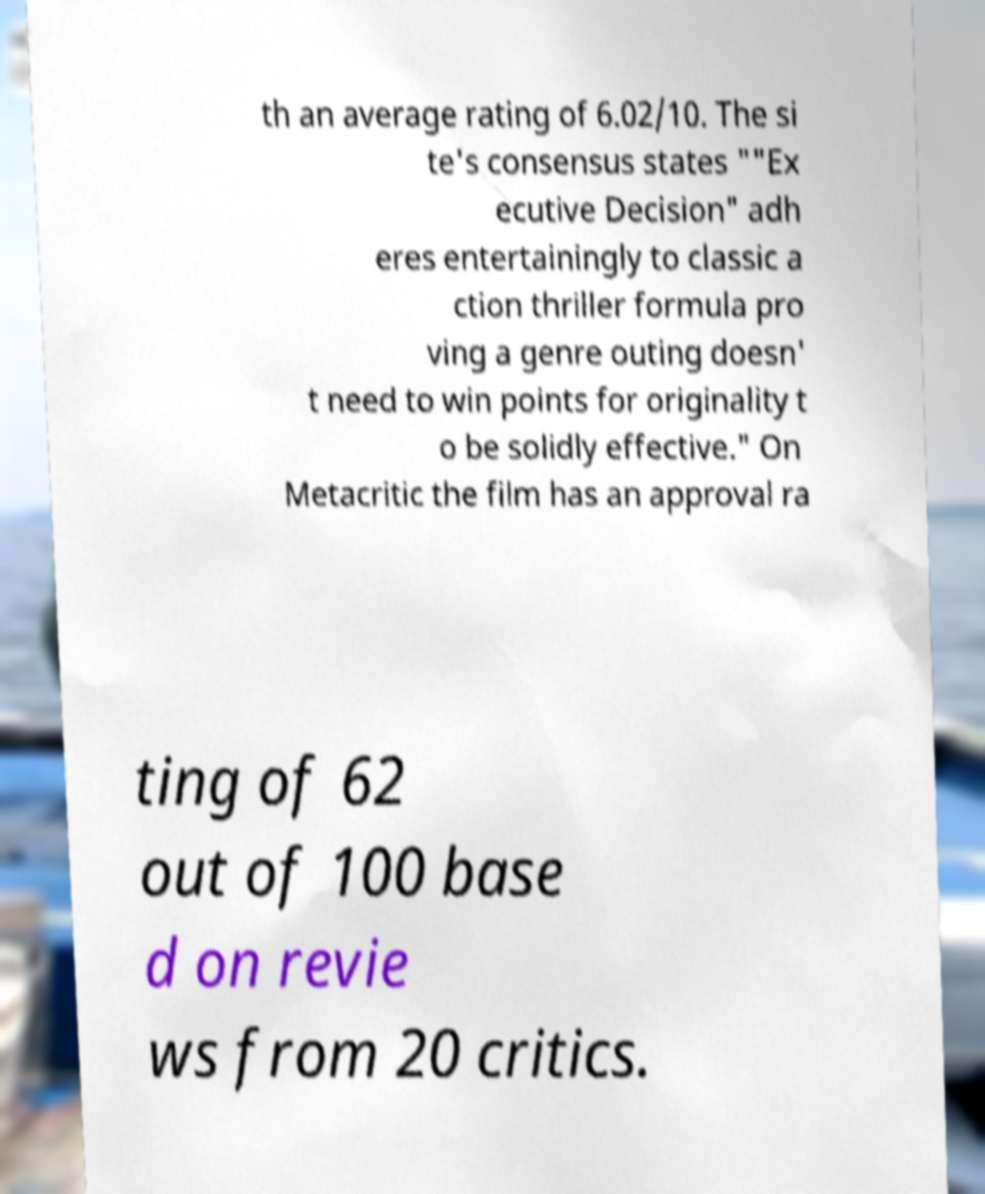Please identify and transcribe the text found in this image. th an average rating of 6.02/10. The si te's consensus states ""Ex ecutive Decision" adh eres entertainingly to classic a ction thriller formula pro ving a genre outing doesn' t need to win points for originality t o be solidly effective." On Metacritic the film has an approval ra ting of 62 out of 100 base d on revie ws from 20 critics. 